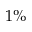Convert formula to latex. <formula><loc_0><loc_0><loc_500><loc_500>1 \%</formula> 